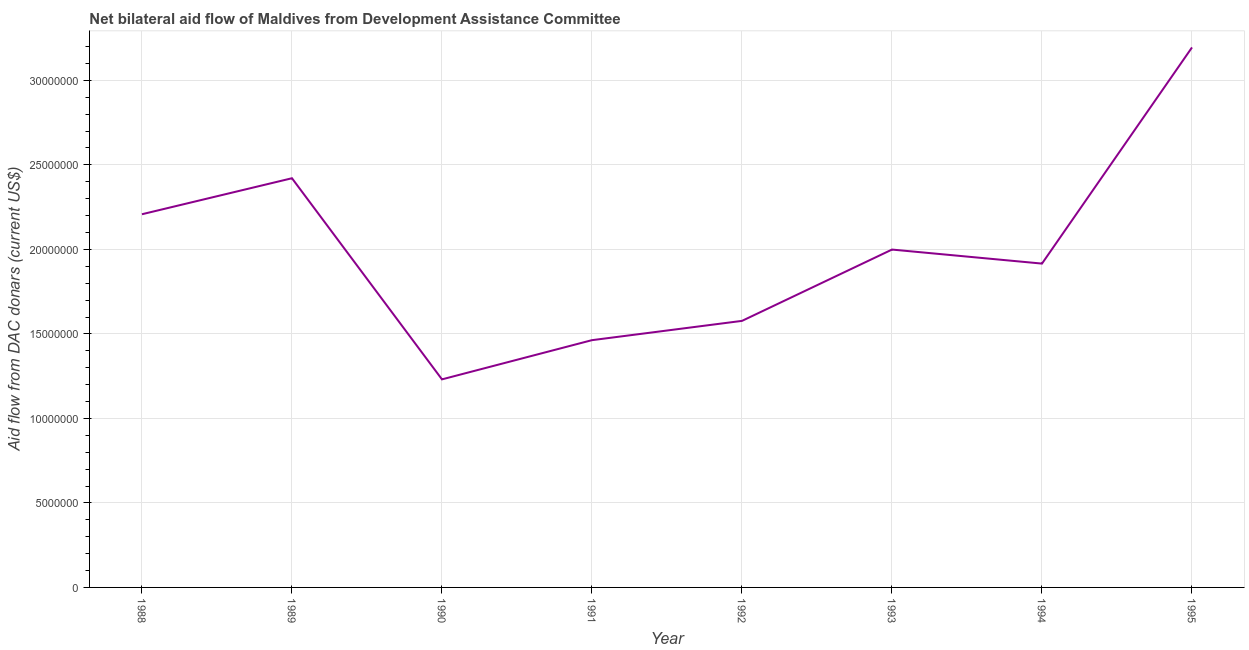What is the net bilateral aid flows from dac donors in 1989?
Offer a very short reply. 2.42e+07. Across all years, what is the maximum net bilateral aid flows from dac donors?
Keep it short and to the point. 3.20e+07. Across all years, what is the minimum net bilateral aid flows from dac donors?
Provide a short and direct response. 1.23e+07. What is the sum of the net bilateral aid flows from dac donors?
Offer a terse response. 1.60e+08. What is the difference between the net bilateral aid flows from dac donors in 1991 and 1994?
Your answer should be very brief. -4.53e+06. What is the average net bilateral aid flows from dac donors per year?
Offer a terse response. 2.00e+07. What is the median net bilateral aid flows from dac donors?
Provide a succinct answer. 1.96e+07. Do a majority of the years between 1990 and 1988 (inclusive) have net bilateral aid flows from dac donors greater than 11000000 US$?
Offer a very short reply. No. What is the ratio of the net bilateral aid flows from dac donors in 1988 to that in 1995?
Your response must be concise. 0.69. Is the net bilateral aid flows from dac donors in 1992 less than that in 1995?
Your response must be concise. Yes. What is the difference between the highest and the second highest net bilateral aid flows from dac donors?
Provide a short and direct response. 7.74e+06. Is the sum of the net bilateral aid flows from dac donors in 1992 and 1995 greater than the maximum net bilateral aid flows from dac donors across all years?
Offer a terse response. Yes. What is the difference between the highest and the lowest net bilateral aid flows from dac donors?
Your response must be concise. 1.96e+07. In how many years, is the net bilateral aid flows from dac donors greater than the average net bilateral aid flows from dac donors taken over all years?
Give a very brief answer. 3. Does the net bilateral aid flows from dac donors monotonically increase over the years?
Your answer should be compact. No. How many lines are there?
Offer a very short reply. 1. What is the difference between two consecutive major ticks on the Y-axis?
Provide a succinct answer. 5.00e+06. What is the title of the graph?
Your response must be concise. Net bilateral aid flow of Maldives from Development Assistance Committee. What is the label or title of the X-axis?
Keep it short and to the point. Year. What is the label or title of the Y-axis?
Your answer should be compact. Aid flow from DAC donars (current US$). What is the Aid flow from DAC donars (current US$) in 1988?
Give a very brief answer. 2.21e+07. What is the Aid flow from DAC donars (current US$) of 1989?
Give a very brief answer. 2.42e+07. What is the Aid flow from DAC donars (current US$) in 1990?
Give a very brief answer. 1.23e+07. What is the Aid flow from DAC donars (current US$) in 1991?
Your response must be concise. 1.46e+07. What is the Aid flow from DAC donars (current US$) in 1992?
Make the answer very short. 1.58e+07. What is the Aid flow from DAC donars (current US$) of 1993?
Ensure brevity in your answer.  2.00e+07. What is the Aid flow from DAC donars (current US$) in 1994?
Give a very brief answer. 1.92e+07. What is the Aid flow from DAC donars (current US$) in 1995?
Keep it short and to the point. 3.20e+07. What is the difference between the Aid flow from DAC donars (current US$) in 1988 and 1989?
Your response must be concise. -2.13e+06. What is the difference between the Aid flow from DAC donars (current US$) in 1988 and 1990?
Your answer should be compact. 9.77e+06. What is the difference between the Aid flow from DAC donars (current US$) in 1988 and 1991?
Provide a short and direct response. 7.45e+06. What is the difference between the Aid flow from DAC donars (current US$) in 1988 and 1992?
Keep it short and to the point. 6.31e+06. What is the difference between the Aid flow from DAC donars (current US$) in 1988 and 1993?
Your answer should be very brief. 2.09e+06. What is the difference between the Aid flow from DAC donars (current US$) in 1988 and 1994?
Offer a terse response. 2.92e+06. What is the difference between the Aid flow from DAC donars (current US$) in 1988 and 1995?
Your answer should be compact. -9.87e+06. What is the difference between the Aid flow from DAC donars (current US$) in 1989 and 1990?
Offer a terse response. 1.19e+07. What is the difference between the Aid flow from DAC donars (current US$) in 1989 and 1991?
Offer a very short reply. 9.58e+06. What is the difference between the Aid flow from DAC donars (current US$) in 1989 and 1992?
Give a very brief answer. 8.44e+06. What is the difference between the Aid flow from DAC donars (current US$) in 1989 and 1993?
Your answer should be very brief. 4.22e+06. What is the difference between the Aid flow from DAC donars (current US$) in 1989 and 1994?
Offer a very short reply. 5.05e+06. What is the difference between the Aid flow from DAC donars (current US$) in 1989 and 1995?
Provide a succinct answer. -7.74e+06. What is the difference between the Aid flow from DAC donars (current US$) in 1990 and 1991?
Your response must be concise. -2.32e+06. What is the difference between the Aid flow from DAC donars (current US$) in 1990 and 1992?
Keep it short and to the point. -3.46e+06. What is the difference between the Aid flow from DAC donars (current US$) in 1990 and 1993?
Offer a terse response. -7.68e+06. What is the difference between the Aid flow from DAC donars (current US$) in 1990 and 1994?
Give a very brief answer. -6.85e+06. What is the difference between the Aid flow from DAC donars (current US$) in 1990 and 1995?
Your answer should be compact. -1.96e+07. What is the difference between the Aid flow from DAC donars (current US$) in 1991 and 1992?
Your answer should be compact. -1.14e+06. What is the difference between the Aid flow from DAC donars (current US$) in 1991 and 1993?
Provide a succinct answer. -5.36e+06. What is the difference between the Aid flow from DAC donars (current US$) in 1991 and 1994?
Make the answer very short. -4.53e+06. What is the difference between the Aid flow from DAC donars (current US$) in 1991 and 1995?
Make the answer very short. -1.73e+07. What is the difference between the Aid flow from DAC donars (current US$) in 1992 and 1993?
Keep it short and to the point. -4.22e+06. What is the difference between the Aid flow from DAC donars (current US$) in 1992 and 1994?
Keep it short and to the point. -3.39e+06. What is the difference between the Aid flow from DAC donars (current US$) in 1992 and 1995?
Your response must be concise. -1.62e+07. What is the difference between the Aid flow from DAC donars (current US$) in 1993 and 1994?
Ensure brevity in your answer.  8.30e+05. What is the difference between the Aid flow from DAC donars (current US$) in 1993 and 1995?
Provide a succinct answer. -1.20e+07. What is the difference between the Aid flow from DAC donars (current US$) in 1994 and 1995?
Ensure brevity in your answer.  -1.28e+07. What is the ratio of the Aid flow from DAC donars (current US$) in 1988 to that in 1989?
Offer a very short reply. 0.91. What is the ratio of the Aid flow from DAC donars (current US$) in 1988 to that in 1990?
Make the answer very short. 1.79. What is the ratio of the Aid flow from DAC donars (current US$) in 1988 to that in 1991?
Ensure brevity in your answer.  1.51. What is the ratio of the Aid flow from DAC donars (current US$) in 1988 to that in 1993?
Provide a succinct answer. 1.1. What is the ratio of the Aid flow from DAC donars (current US$) in 1988 to that in 1994?
Give a very brief answer. 1.15. What is the ratio of the Aid flow from DAC donars (current US$) in 1988 to that in 1995?
Your response must be concise. 0.69. What is the ratio of the Aid flow from DAC donars (current US$) in 1989 to that in 1990?
Give a very brief answer. 1.97. What is the ratio of the Aid flow from DAC donars (current US$) in 1989 to that in 1991?
Ensure brevity in your answer.  1.66. What is the ratio of the Aid flow from DAC donars (current US$) in 1989 to that in 1992?
Your response must be concise. 1.53. What is the ratio of the Aid flow from DAC donars (current US$) in 1989 to that in 1993?
Keep it short and to the point. 1.21. What is the ratio of the Aid flow from DAC donars (current US$) in 1989 to that in 1994?
Offer a terse response. 1.26. What is the ratio of the Aid flow from DAC donars (current US$) in 1989 to that in 1995?
Give a very brief answer. 0.76. What is the ratio of the Aid flow from DAC donars (current US$) in 1990 to that in 1991?
Your response must be concise. 0.84. What is the ratio of the Aid flow from DAC donars (current US$) in 1990 to that in 1992?
Provide a short and direct response. 0.78. What is the ratio of the Aid flow from DAC donars (current US$) in 1990 to that in 1993?
Make the answer very short. 0.62. What is the ratio of the Aid flow from DAC donars (current US$) in 1990 to that in 1994?
Your answer should be very brief. 0.64. What is the ratio of the Aid flow from DAC donars (current US$) in 1990 to that in 1995?
Offer a terse response. 0.39. What is the ratio of the Aid flow from DAC donars (current US$) in 1991 to that in 1992?
Give a very brief answer. 0.93. What is the ratio of the Aid flow from DAC donars (current US$) in 1991 to that in 1993?
Offer a terse response. 0.73. What is the ratio of the Aid flow from DAC donars (current US$) in 1991 to that in 1994?
Your answer should be compact. 0.76. What is the ratio of the Aid flow from DAC donars (current US$) in 1991 to that in 1995?
Ensure brevity in your answer.  0.46. What is the ratio of the Aid flow from DAC donars (current US$) in 1992 to that in 1993?
Your answer should be very brief. 0.79. What is the ratio of the Aid flow from DAC donars (current US$) in 1992 to that in 1994?
Your answer should be compact. 0.82. What is the ratio of the Aid flow from DAC donars (current US$) in 1992 to that in 1995?
Make the answer very short. 0.49. What is the ratio of the Aid flow from DAC donars (current US$) in 1993 to that in 1994?
Provide a succinct answer. 1.04. What is the ratio of the Aid flow from DAC donars (current US$) in 1993 to that in 1995?
Ensure brevity in your answer.  0.63. 